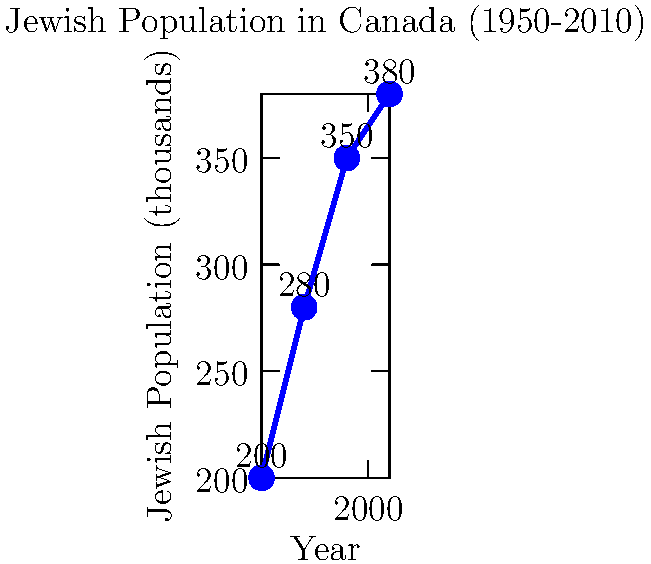Based on the geometric representation of Jewish population distribution in Canada from 1950 to 2010, calculate the average rate of population growth per decade. Express your answer as a percentage, rounded to one decimal place. To solve this problem, we'll follow these steps:

1. Calculate the total population change:
   Final population (2010) - Initial population (1950)
   $380,000 - 200,000 = 180,000$

2. Calculate the number of decades:
   (2010 - 1950) / 10 = 6 decades

3. Calculate the average growth per decade:
   $180,000 \div 6 = 30,000$

4. Express this as a percentage of the initial population:
   $(30,000 \div 200,000) \times 100 = 15\%$

5. Calculate the compound growth rate:
   Let $r$ be the growth rate per decade.
   $(1 + r)^6 = 380,000 / 200,000 = 1.9$
   $1 + r = 1.9^{\frac{1}{6}} \approx 1.111$
   $r \approx 0.111$ or $11.1\%$

Therefore, the average rate of population growth per decade is approximately 11.1%.
Answer: 11.1% 